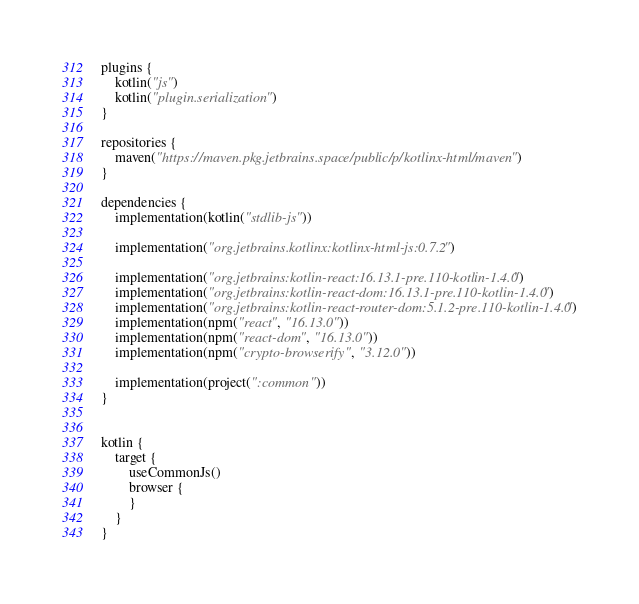Convert code to text. <code><loc_0><loc_0><loc_500><loc_500><_Kotlin_>plugins {
    kotlin("js")
    kotlin("plugin.serialization")
}

repositories {
    maven("https://maven.pkg.jetbrains.space/public/p/kotlinx-html/maven")
}

dependencies {
    implementation(kotlin("stdlib-js"))

    implementation("org.jetbrains.kotlinx:kotlinx-html-js:0.7.2")

    implementation("org.jetbrains:kotlin-react:16.13.1-pre.110-kotlin-1.4.0")
    implementation("org.jetbrains:kotlin-react-dom:16.13.1-pre.110-kotlin-1.4.0")
    implementation("org.jetbrains:kotlin-react-router-dom:5.1.2-pre.110-kotlin-1.4.0")
    implementation(npm("react", "16.13.0"))
    implementation(npm("react-dom", "16.13.0"))
    implementation(npm("crypto-browserify", "3.12.0"))

    implementation(project(":common"))
}


kotlin {
    target {
        useCommonJs()
        browser {
        }
    }
}</code> 